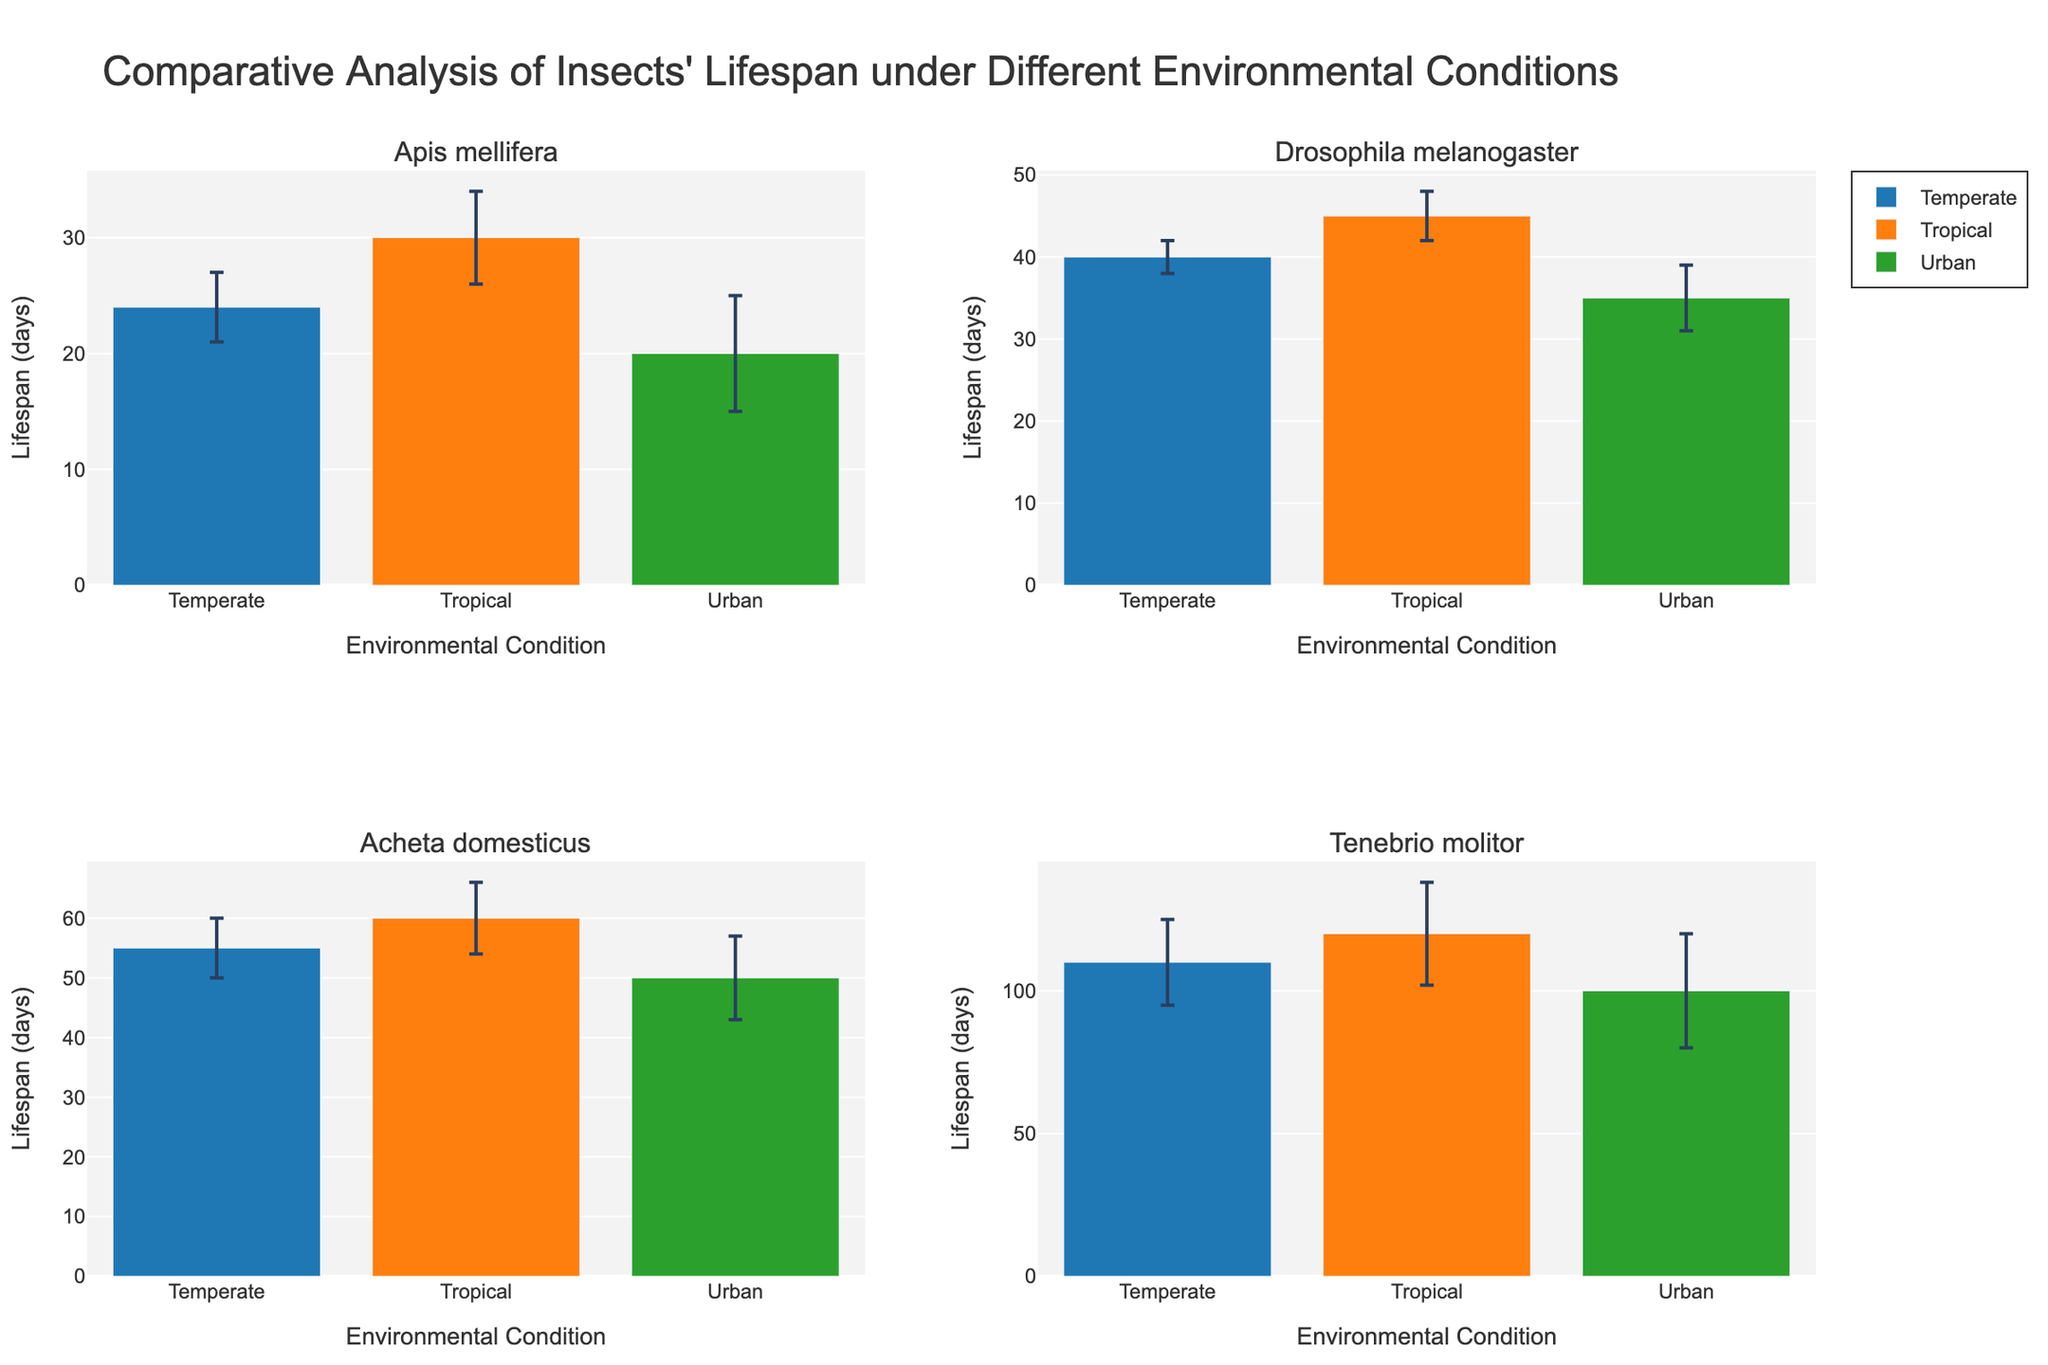What is the title of the figure? The title is displayed prominently at the top of the figure. It reads "Comparative Analysis of Insects' Lifespan under Different Environmental Conditions."
Answer: Comparative Analysis of Insects' Lifespan under Different Environmental Conditions Which species has the highest average lifespan in the tropical condition? The species with the highest average lifespan under tropical conditions is listed in the chart. "Tenebrio molitor" has the highest lifespan with a mean of 120 days.
Answer: Tenebrio molitor What are the three environmental conditions shown on the x-axes? The x-axes of each subplot show three environmental conditions. They are "Temperate," "Tropical," and "Urban."
Answer: Temperate, Tropical, Urban Which insect species has the smallest standard deviation in lifespan under any condition? By inspecting the error bars for each species, we determine that "Drosophila melanogaster" under "Temperate" conditions has the smallest error bar, indicating a standard deviation of 2 days.
Answer: Drosophila melanogaster What is the mean lifespan difference between Acheta domesticus under tropical and urban conditions? Calculate the mean lifespans: 60 days (Tropical) and 50 days (Urban). The difference is 60 - 50, so 10 days.
Answer: 10 days How does the lifespan of Tenebrio molitor in temperate conditions compare with Drosophila melanogaster in urban conditions? Tenebrio molitor has a mean lifespan of 110 days in Temperate conditions. Drosophila melanogaster has a mean lifespan of 35 days in Urban conditions. Tenebrio molitor lives significantly longer.
Answer: Tenebrio molitor lives longer Which conditions have the largest and smallest standard deviations in the tropical environment? Look at the error bars in the tropical condition.
- Smallest: Drosophila melanogaster (3 days)
- Largest: Tenebrio molitor (18 days)
Answer: Drosophila melanogaster (smallest), Tenebrio molitor (largest) What is the combined mean lifespan of Apis mellifera across all environmental conditions? Calculate the sum of the mean lifespans: 24 (Temperate) + 30 (Tropical) + 20 (Urban) = 74 days. This is the total mean lifespan across conditions.
Answer: 74 days Which species shows the greatest variance in lifespan across different environmental conditions? The variance can be visually estimated by the length of error bars across different conditions. Tenebrio molitor has the largest range of lifespan when comparing Temperate, Tropical, and Urban conditions (Standard Deviation of 15, 18, and 20 days respectively).
Answer: Tenebrio molitor 